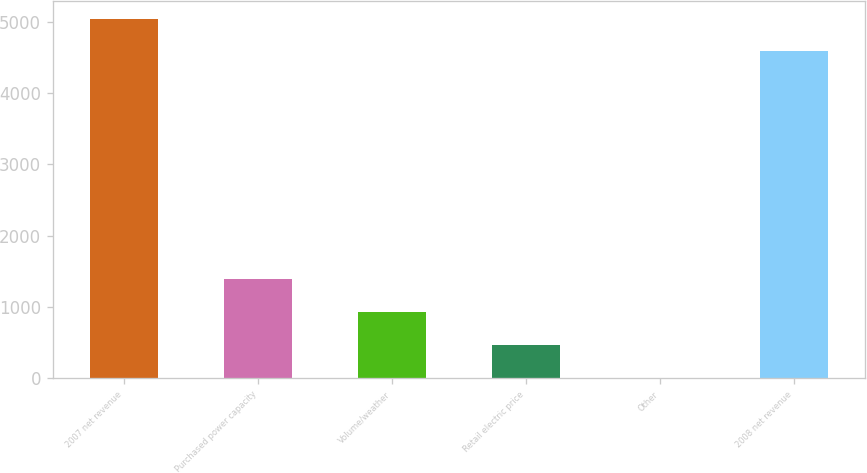Convert chart to OTSL. <chart><loc_0><loc_0><loc_500><loc_500><bar_chart><fcel>2007 net revenue<fcel>Purchased power capacity<fcel>Volume/weather<fcel>Retail electric price<fcel>Other<fcel>2008 net revenue<nl><fcel>5050.7<fcel>1386.1<fcel>924.4<fcel>462.7<fcel>1<fcel>4589<nl></chart> 